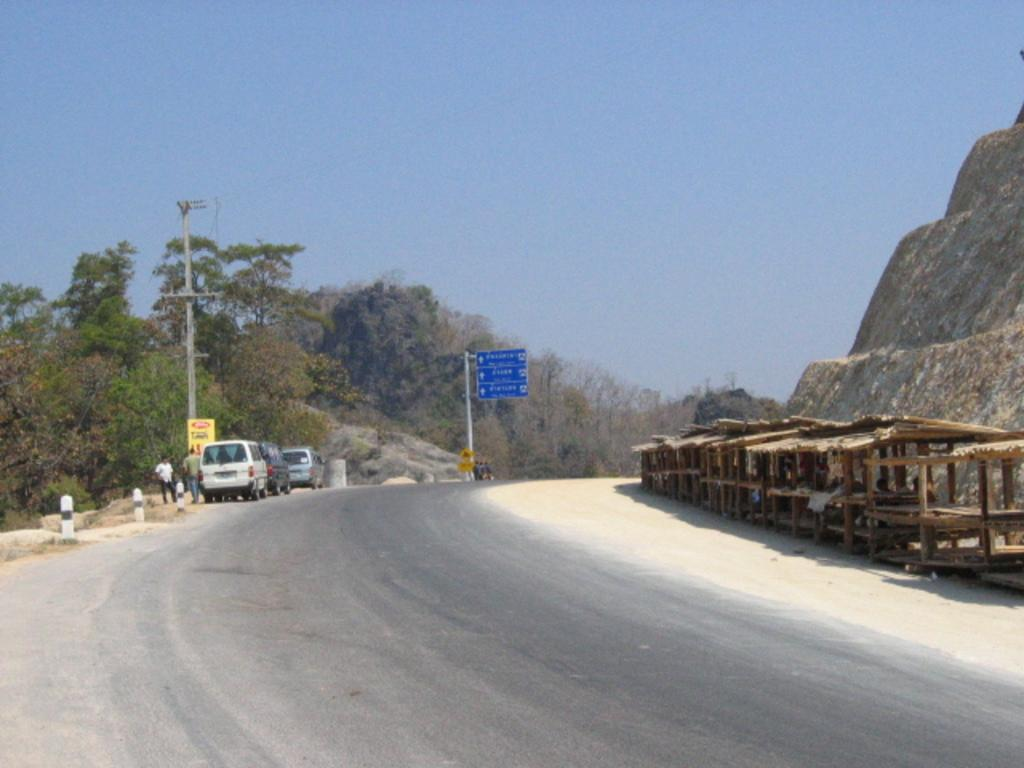What is the main feature of the image? There is a road in the image. What else can be seen on the road? There are vehicles in the image. What structures are present alongside the road? There are poles and boards in the image. What type of natural environment is visible in the image? There are trees and a mountain in the image. Are there any living beings in the image? Yes, there are people in the image. What else can be observed in the image? There are other objects in the image, and the sky is visible in the background. How many babies are holding spoons in the image? There are no babies or spoons present in the image. What type of engine is visible in the image? There is no engine visible in the image. 